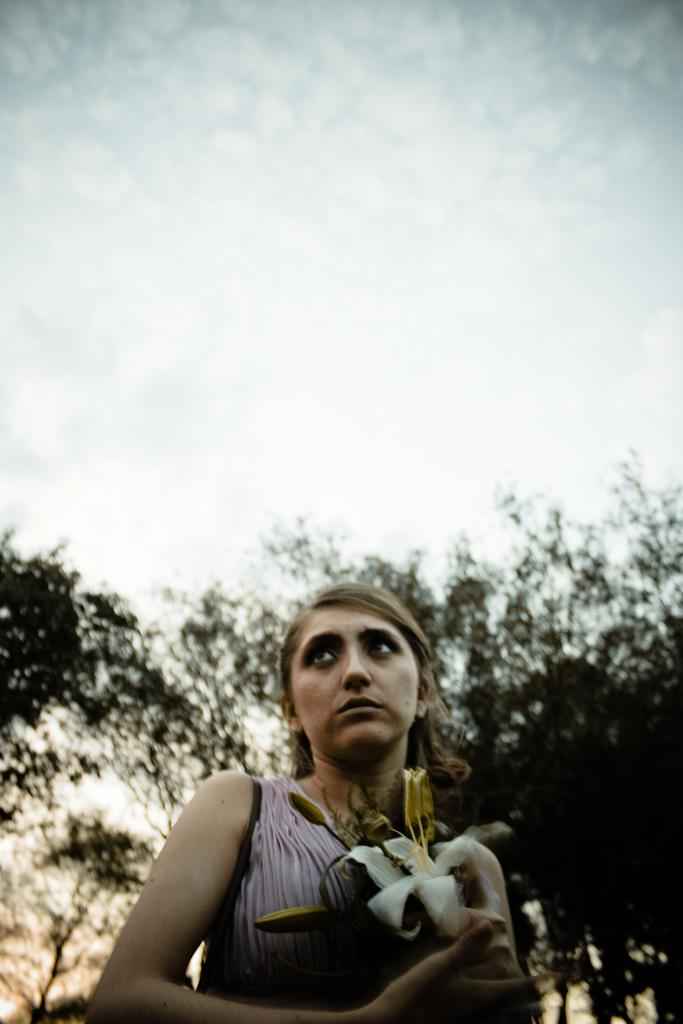Who is present in the image? There is a woman in the image. What is the woman holding in the image? The woman is holding flowers. What can be seen in the background of the image? There are trees and the sky visible in the background of the image. How would you describe the sky in the image? The sky appears to be cloudy in the image. What type of apparel is the baby wearing in the image? There is no baby present in the image, so it is not possible to answer that question. 